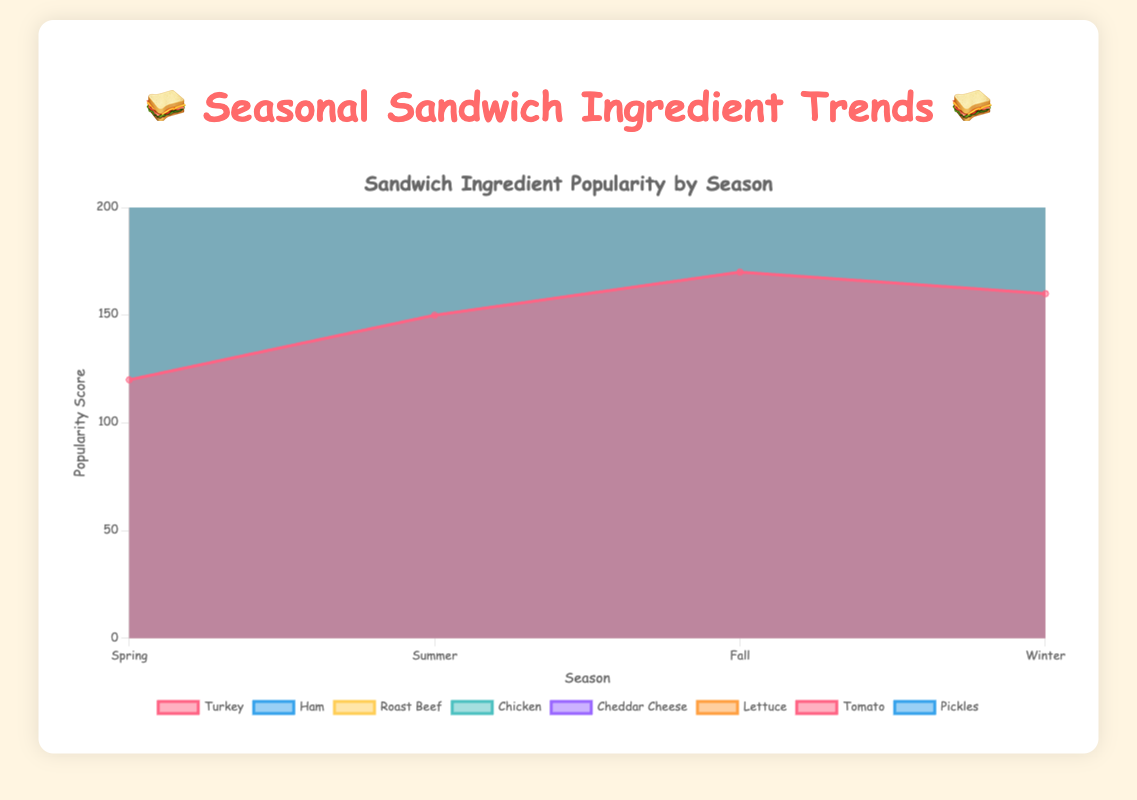What is the most popular ingredient during summer? To find the most popular ingredient during summer, look at the summer section of the area chart and identify which line is the highest. The highest point in summer is for Tomato at 180.
Answer: Tomato How does the popularity of Chicken change from spring to winter? Find the Chicken line and check its values from spring (110) to winter (120). Chicken increases in popularity in summer to 160, then decreases to 130 in fall, and finally slightly declines to 120 in winter.
Answer: Decreases, then increases Which ingredient shows the most consistent popularity across all seasons? Consistency can be observed by minimum changes in height/values across seasons. Cheddar Cheese has values 130, 140, 150, 140. These values show the smallest range of fluctuation compared to others.
Answer: Cheddar Cheese Is Turkey more popular in spring or fall? Locate Turkey's values for spring (120) and fall (170). Since 170 is higher than 120, Turkey is more popular in fall.
Answer: Fall What is the least popular ingredient in winter? To find this, look at winter values for all ingredients. Pickles at 70 is the lowest.
Answer: Pickles What ingredient experiences the largest drop in popularity from summer to fall? Compare the values of summer and fall for each ingredient and calculate the differences. Lettuce drops from 170 to 130, a decrease of 40, which is the largest drop.
Answer: Lettuce How many ingredients have a peak popularity in summer? Review the chart and identify which lines reach their highest point in summer. Turkey, Chicken, Lettuce, Tomato, and Pickles reach their peak in summer. Count them to find that 5 ingredients peak in summer.
Answer: 5 Which ingredient has the highest increase in popularity from spring to summer? Calculate the change from spring to summer for all ingredients. Tomatos jumps from 150 to 180, an increase of 30. This is the highest increase.
Answer: Tomato Considering the average popularity, which ingredient would rank the highest? Calculate the average for each ingredient across all seasons: 
Turkey: (120+150+170+160)/4=150. Ham: (100+130+140+110)/4=120. Roast Beef: (90+120+160+140)/4=127.5. Chicken: (110+160+130+120)/4=130. Cheddar Cheese: (130+140+150+140)/4=140. Lettuce: (140+170+130+100)/4=135. Tomato: (150+180+140+110)/4=145. Pickle: (80+100+90+70)/4=85. Turkey has the highest average of 150.
Answer: Turkey 